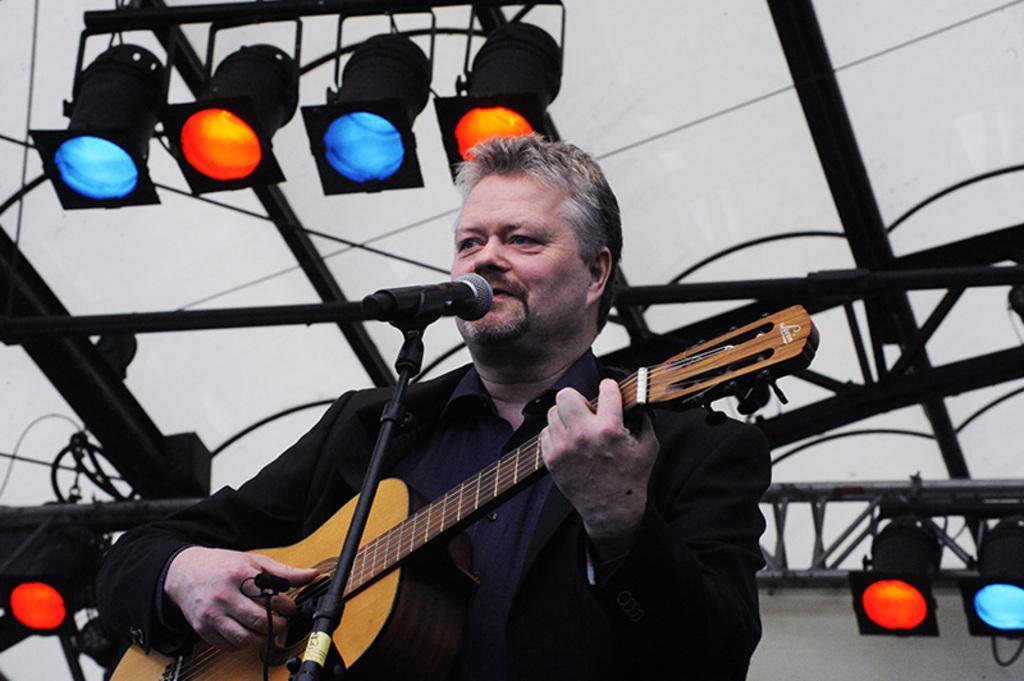How would you summarize this image in a sentence or two? A man is holding guitar and playing and singing. In front of him there is a mic and a mic stand. In the back there are blue and red lights. 